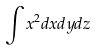Convert formula to latex. <formula><loc_0><loc_0><loc_500><loc_500>\int x ^ { 2 } d x d y d z</formula> 